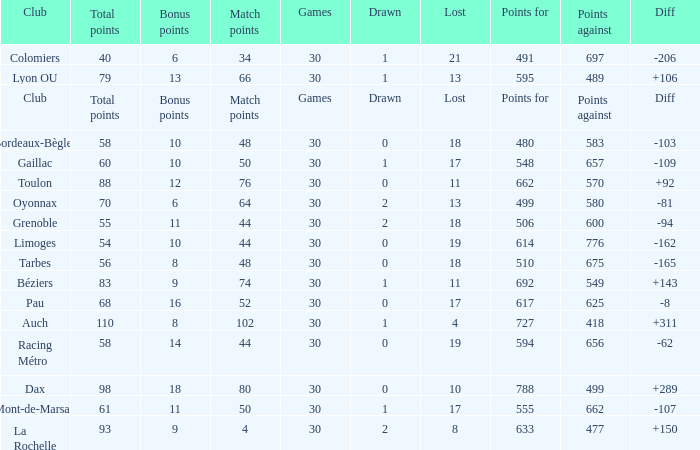What is the number of games for a club that has a value of 595 for points for? 30.0. 